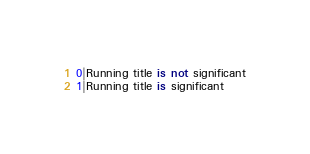<code> <loc_0><loc_0><loc_500><loc_500><_SQL_>0|Running title is not significant
1|Running title is significant</code> 